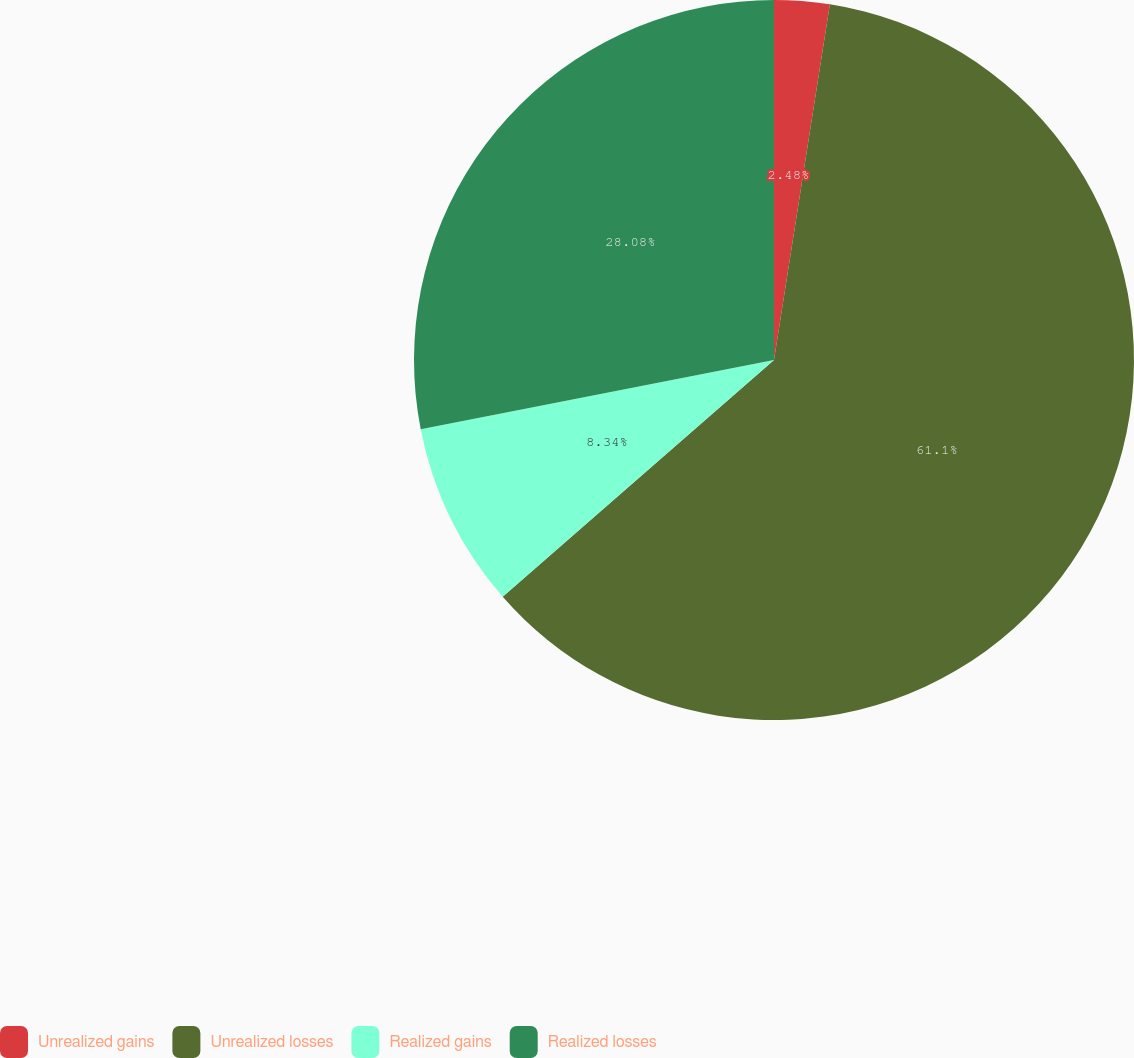Convert chart to OTSL. <chart><loc_0><loc_0><loc_500><loc_500><pie_chart><fcel>Unrealized gains<fcel>Unrealized losses<fcel>Realized gains<fcel>Realized losses<nl><fcel>2.48%<fcel>61.11%<fcel>8.34%<fcel>28.08%<nl></chart> 